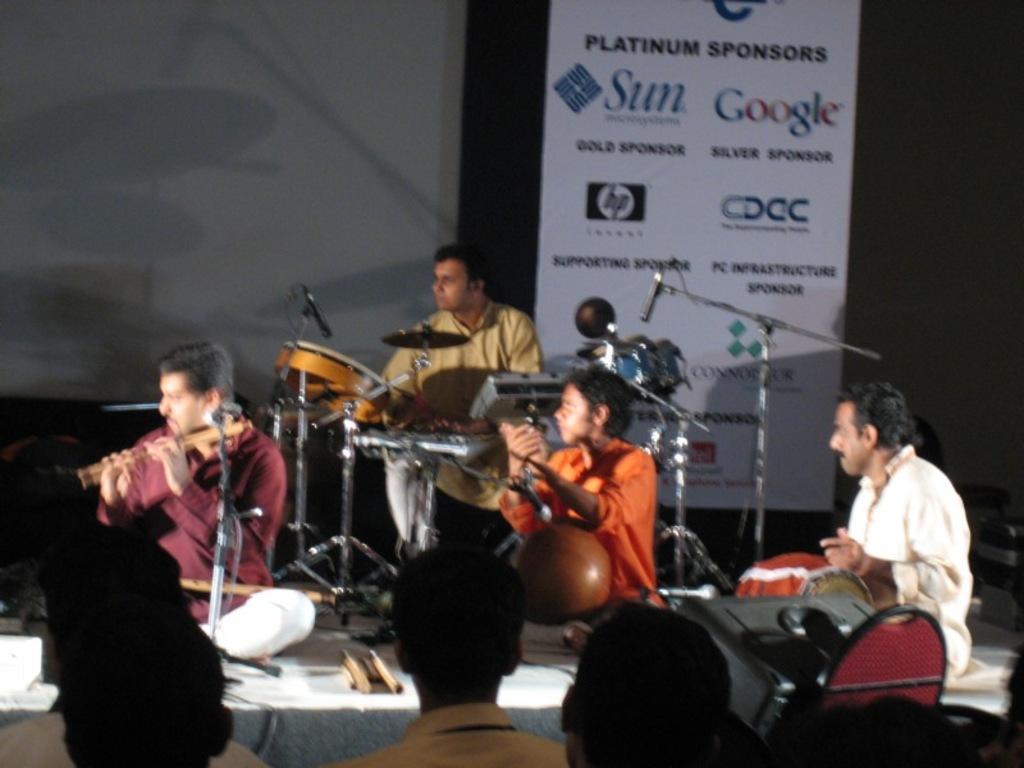Describe this image in one or two sentences. There are group of men sitting on the stage who are playing different musical instruments. In the background, there is a list of sponsors for the concert. In the down, there are some audience who are watching them. 